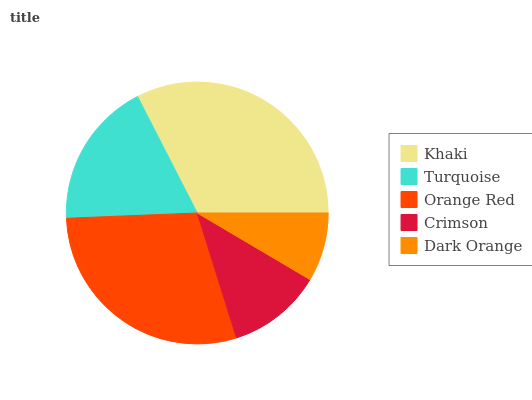Is Dark Orange the minimum?
Answer yes or no. Yes. Is Khaki the maximum?
Answer yes or no. Yes. Is Turquoise the minimum?
Answer yes or no. No. Is Turquoise the maximum?
Answer yes or no. No. Is Khaki greater than Turquoise?
Answer yes or no. Yes. Is Turquoise less than Khaki?
Answer yes or no. Yes. Is Turquoise greater than Khaki?
Answer yes or no. No. Is Khaki less than Turquoise?
Answer yes or no. No. Is Turquoise the high median?
Answer yes or no. Yes. Is Turquoise the low median?
Answer yes or no. Yes. Is Khaki the high median?
Answer yes or no. No. Is Dark Orange the low median?
Answer yes or no. No. 